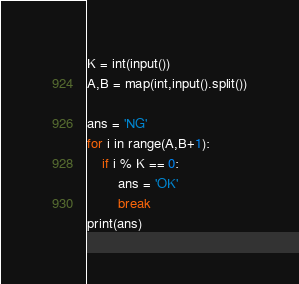<code> <loc_0><loc_0><loc_500><loc_500><_Python_>K = int(input())
A,B = map(int,input().split())

ans = 'NG'
for i in range(A,B+1):
    if i % K == 0:
        ans = 'OK'
        break
print(ans)</code> 